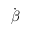Convert formula to latex. <formula><loc_0><loc_0><loc_500><loc_500>\dot { \beta }</formula> 